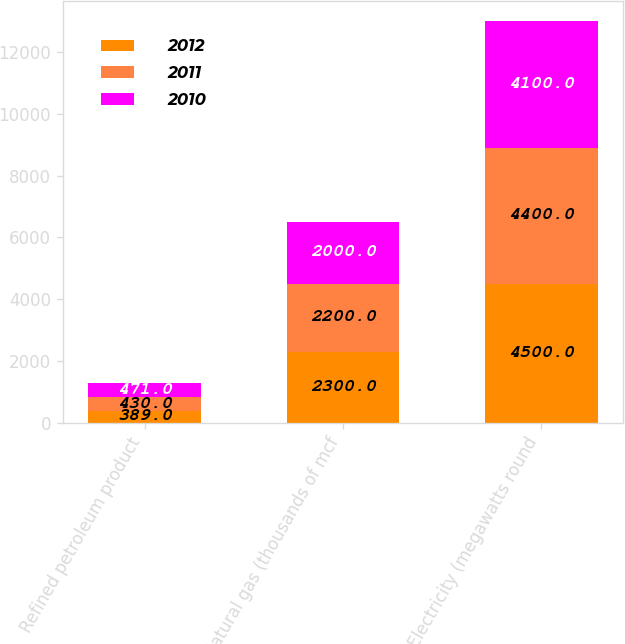Convert chart. <chart><loc_0><loc_0><loc_500><loc_500><stacked_bar_chart><ecel><fcel>Refined petroleum product<fcel>Natural gas (thousands of mcf<fcel>Electricity (megawatts round<nl><fcel>2012<fcel>389<fcel>2300<fcel>4500<nl><fcel>2011<fcel>430<fcel>2200<fcel>4400<nl><fcel>2010<fcel>471<fcel>2000<fcel>4100<nl></chart> 